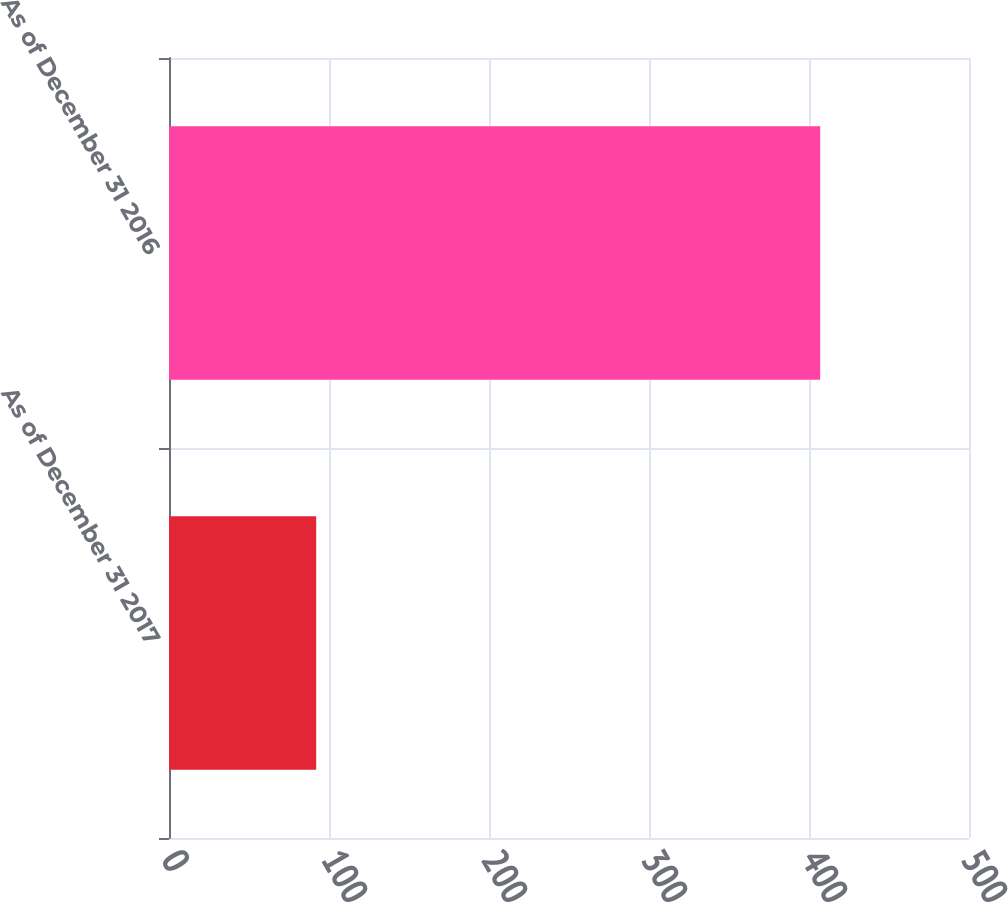<chart> <loc_0><loc_0><loc_500><loc_500><bar_chart><fcel>As of December 31 2017<fcel>As of December 31 2016<nl><fcel>92<fcel>407<nl></chart> 